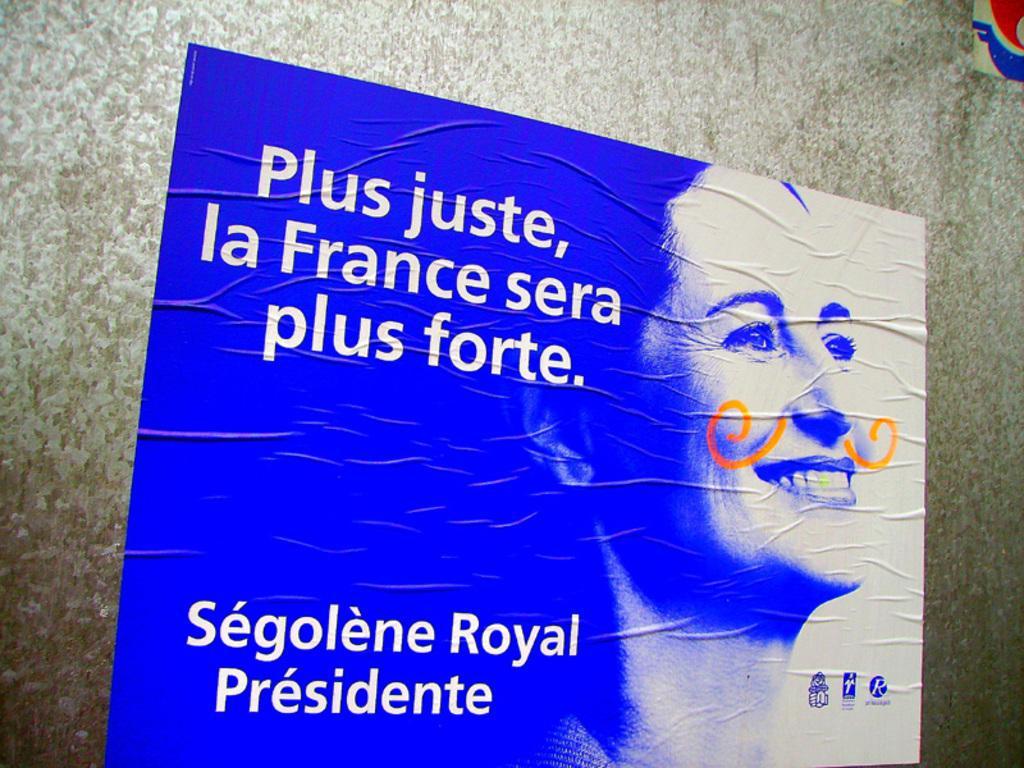How would you summarize this image in a sentence or two? In this image we can see a poster with an image of a lady and also there is text. In the back there is a wall. 